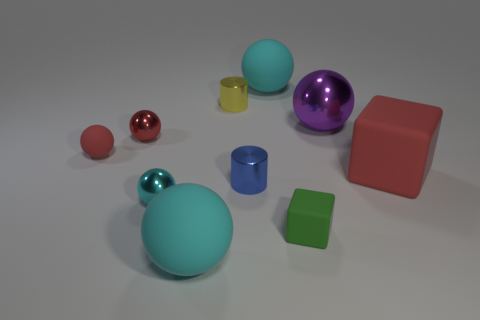How many cyan spheres must be subtracted to get 1 cyan spheres? 2 Subtract all gray blocks. How many cyan balls are left? 3 Subtract all purple balls. How many balls are left? 5 Subtract all big cyan rubber balls. How many balls are left? 4 Subtract all gray spheres. Subtract all red cylinders. How many spheres are left? 6 Subtract all cylinders. How many objects are left? 8 Add 6 tiny cyan metal spheres. How many tiny cyan metal spheres are left? 7 Add 2 big yellow matte spheres. How many big yellow matte spheres exist? 2 Subtract 0 blue cubes. How many objects are left? 10 Subtract all small purple matte balls. Subtract all large cyan rubber objects. How many objects are left? 8 